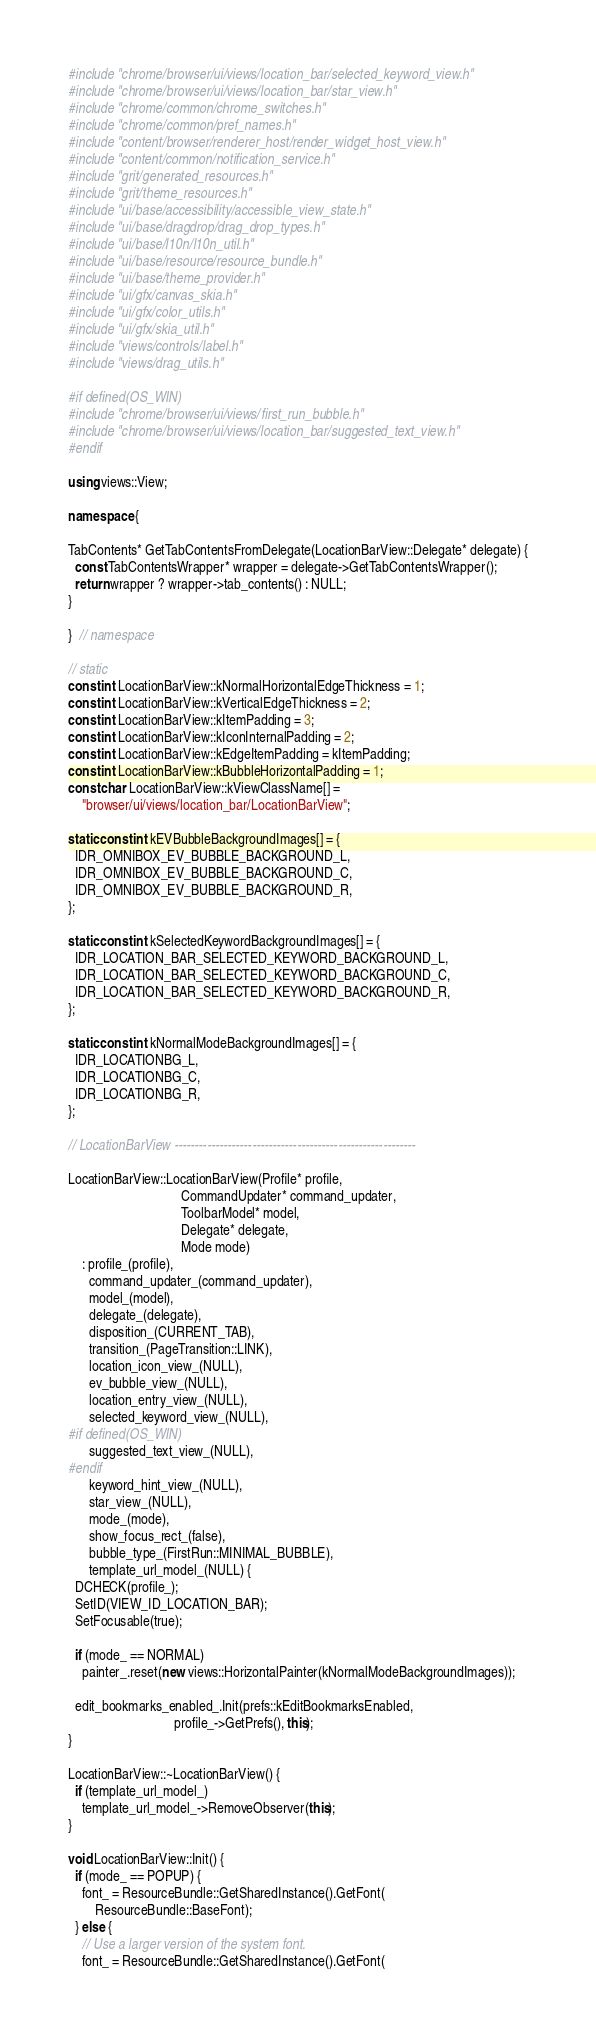<code> <loc_0><loc_0><loc_500><loc_500><_C++_>#include "chrome/browser/ui/views/location_bar/selected_keyword_view.h"
#include "chrome/browser/ui/views/location_bar/star_view.h"
#include "chrome/common/chrome_switches.h"
#include "chrome/common/pref_names.h"
#include "content/browser/renderer_host/render_widget_host_view.h"
#include "content/common/notification_service.h"
#include "grit/generated_resources.h"
#include "grit/theme_resources.h"
#include "ui/base/accessibility/accessible_view_state.h"
#include "ui/base/dragdrop/drag_drop_types.h"
#include "ui/base/l10n/l10n_util.h"
#include "ui/base/resource/resource_bundle.h"
#include "ui/base/theme_provider.h"
#include "ui/gfx/canvas_skia.h"
#include "ui/gfx/color_utils.h"
#include "ui/gfx/skia_util.h"
#include "views/controls/label.h"
#include "views/drag_utils.h"

#if defined(OS_WIN)
#include "chrome/browser/ui/views/first_run_bubble.h"
#include "chrome/browser/ui/views/location_bar/suggested_text_view.h"
#endif

using views::View;

namespace {

TabContents* GetTabContentsFromDelegate(LocationBarView::Delegate* delegate) {
  const TabContentsWrapper* wrapper = delegate->GetTabContentsWrapper();
  return wrapper ? wrapper->tab_contents() : NULL;
}

}  // namespace

// static
const int LocationBarView::kNormalHorizontalEdgeThickness = 1;
const int LocationBarView::kVerticalEdgeThickness = 2;
const int LocationBarView::kItemPadding = 3;
const int LocationBarView::kIconInternalPadding = 2;
const int LocationBarView::kEdgeItemPadding = kItemPadding;
const int LocationBarView::kBubbleHorizontalPadding = 1;
const char LocationBarView::kViewClassName[] =
    "browser/ui/views/location_bar/LocationBarView";

static const int kEVBubbleBackgroundImages[] = {
  IDR_OMNIBOX_EV_BUBBLE_BACKGROUND_L,
  IDR_OMNIBOX_EV_BUBBLE_BACKGROUND_C,
  IDR_OMNIBOX_EV_BUBBLE_BACKGROUND_R,
};

static const int kSelectedKeywordBackgroundImages[] = {
  IDR_LOCATION_BAR_SELECTED_KEYWORD_BACKGROUND_L,
  IDR_LOCATION_BAR_SELECTED_KEYWORD_BACKGROUND_C,
  IDR_LOCATION_BAR_SELECTED_KEYWORD_BACKGROUND_R,
};

static const int kNormalModeBackgroundImages[] = {
  IDR_LOCATIONBG_L,
  IDR_LOCATIONBG_C,
  IDR_LOCATIONBG_R,
};

// LocationBarView -----------------------------------------------------------

LocationBarView::LocationBarView(Profile* profile,
                                 CommandUpdater* command_updater,
                                 ToolbarModel* model,
                                 Delegate* delegate,
                                 Mode mode)
    : profile_(profile),
      command_updater_(command_updater),
      model_(model),
      delegate_(delegate),
      disposition_(CURRENT_TAB),
      transition_(PageTransition::LINK),
      location_icon_view_(NULL),
      ev_bubble_view_(NULL),
      location_entry_view_(NULL),
      selected_keyword_view_(NULL),
#if defined(OS_WIN)
      suggested_text_view_(NULL),
#endif
      keyword_hint_view_(NULL),
      star_view_(NULL),
      mode_(mode),
      show_focus_rect_(false),
      bubble_type_(FirstRun::MINIMAL_BUBBLE),
      template_url_model_(NULL) {
  DCHECK(profile_);
  SetID(VIEW_ID_LOCATION_BAR);
  SetFocusable(true);

  if (mode_ == NORMAL)
    painter_.reset(new views::HorizontalPainter(kNormalModeBackgroundImages));

  edit_bookmarks_enabled_.Init(prefs::kEditBookmarksEnabled,
                               profile_->GetPrefs(), this);
}

LocationBarView::~LocationBarView() {
  if (template_url_model_)
    template_url_model_->RemoveObserver(this);
}

void LocationBarView::Init() {
  if (mode_ == POPUP) {
    font_ = ResourceBundle::GetSharedInstance().GetFont(
        ResourceBundle::BaseFont);
  } else {
    // Use a larger version of the system font.
    font_ = ResourceBundle::GetSharedInstance().GetFont(</code> 